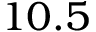<formula> <loc_0><loc_0><loc_500><loc_500>1 0 . 5</formula> 